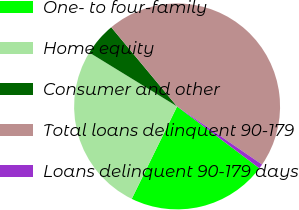Convert chart. <chart><loc_0><loc_0><loc_500><loc_500><pie_chart><fcel>One- to four-family<fcel>Home equity<fcel>Consumer and other<fcel>Total loans delinquent 90-179<fcel>Loans delinquent 90-179 days<nl><fcel>22.01%<fcel>26.5%<fcel>5.2%<fcel>45.59%<fcel>0.71%<nl></chart> 